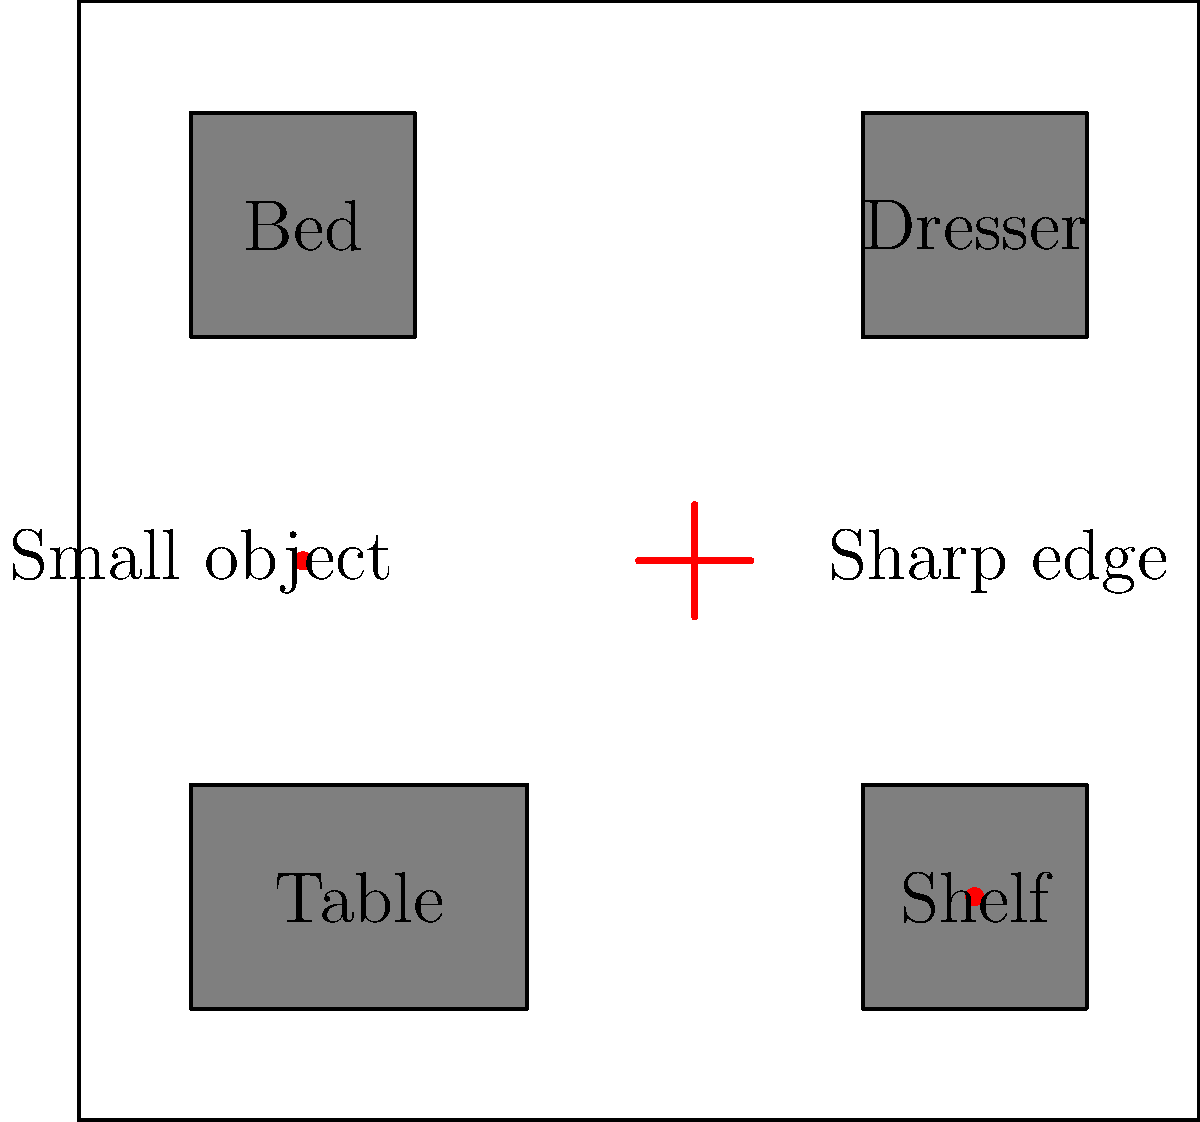Based on the room layout diagram, which features pose the highest risk for hyperactive children, and what modifications would you recommend to create a safer environment? To assess the safety of this room layout for hyperactive children, we need to consider several factors:

1. Sharp edges: The diagram shows a sharp edge in the center of the room, which poses a significant risk for bumps and cuts.

2. Small objects: There are two small objects indicated by red dots, which could be choking hazards or tripping hazards.

3. Furniture placement: The furniture is placed along the walls, which is generally good as it leaves open space in the center. However, the sharp corners of the furniture could still be dangerous.

4. Open space: There is a considerable amount of open space in the center of the room, which is good for movement but could lead to falls if children are running around.

To create a safer environment, we can recommend the following modifications:

1. Cover all sharp edges with padding or corner guards, especially the one in the center of the room.

2. Remove or secure small objects that could be choking or tripping hazards.

3. Add soft padding to furniture corners or choose furniture with rounded edges.

4. Consider adding a soft play mat in the center of the room to cushion potential falls.

5. Ensure all furniture is securely anchored to prevent tipping.

6. Keep the pathways between furniture clear to prevent tripping.

By implementing these changes, we can significantly reduce the risk of accidents for hyperactive children in this room.
Answer: Remove sharp edges and small objects, add padding to furniture corners, and install a soft play mat. 